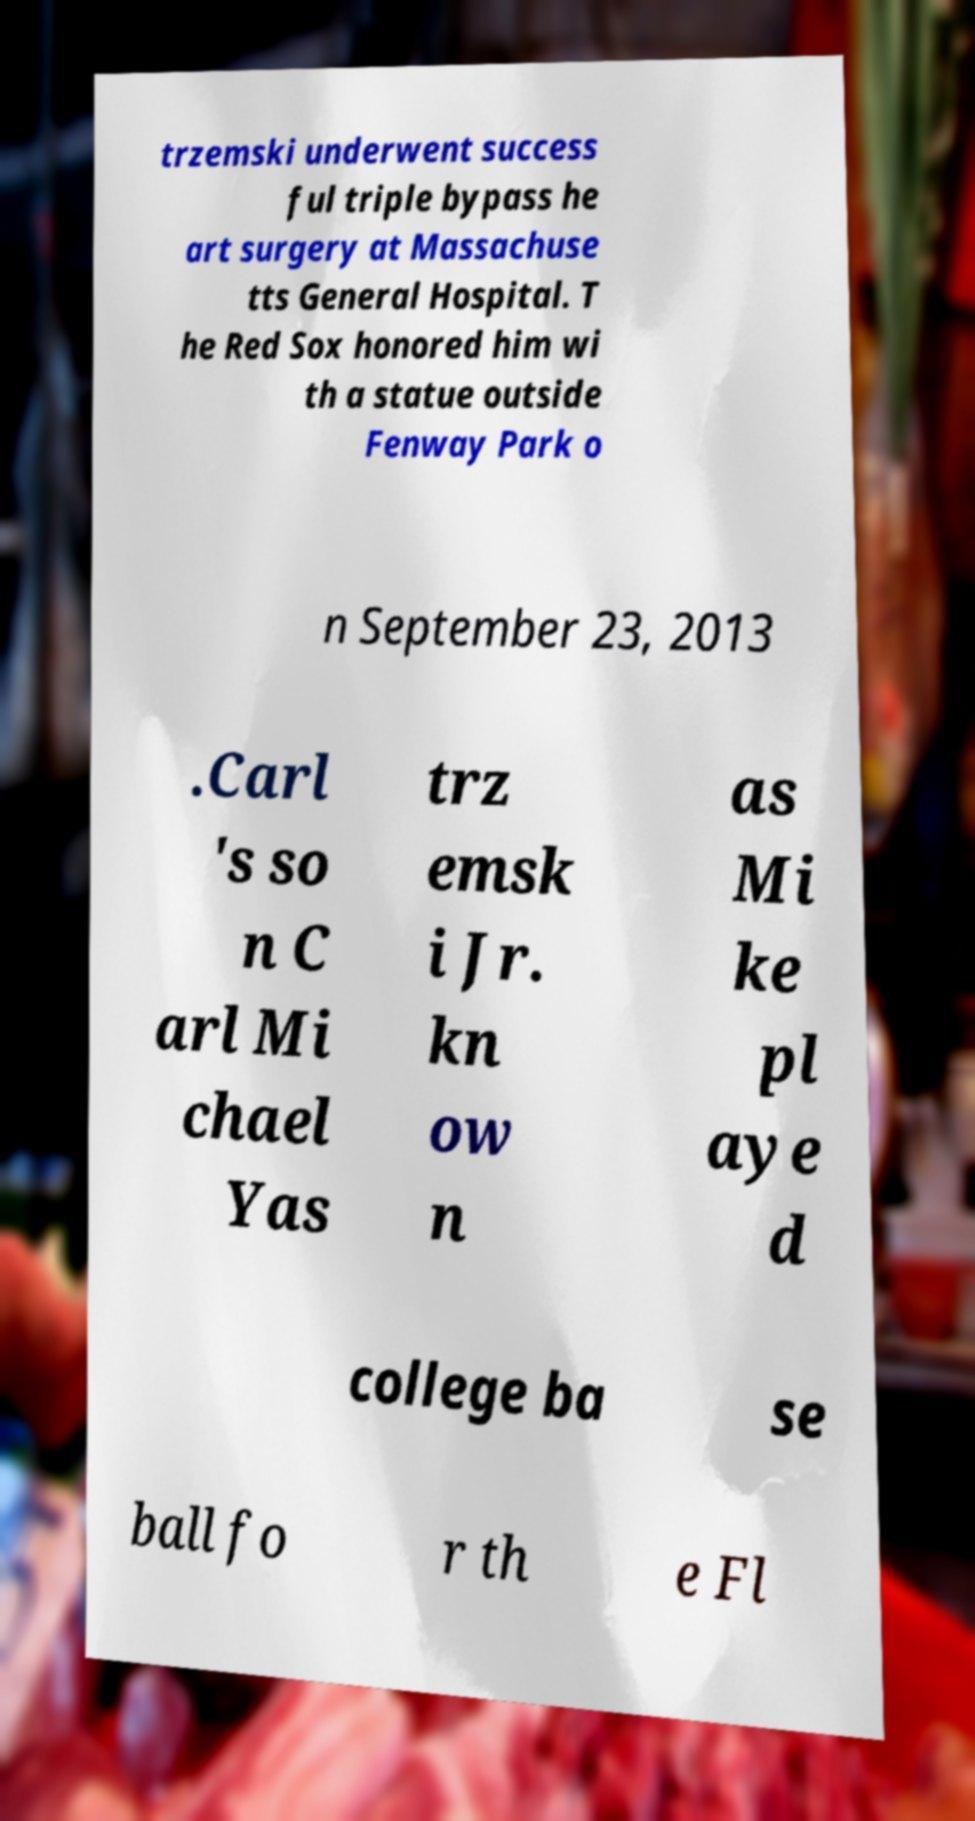Can you read and provide the text displayed in the image?This photo seems to have some interesting text. Can you extract and type it out for me? trzemski underwent success ful triple bypass he art surgery at Massachuse tts General Hospital. T he Red Sox honored him wi th a statue outside Fenway Park o n September 23, 2013 .Carl 's so n C arl Mi chael Yas trz emsk i Jr. kn ow n as Mi ke pl aye d college ba se ball fo r th e Fl 